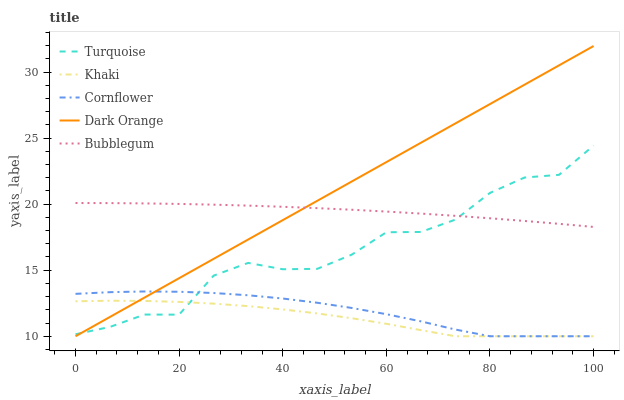Does Khaki have the minimum area under the curve?
Answer yes or no. Yes. Does Dark Orange have the maximum area under the curve?
Answer yes or no. Yes. Does Turquoise have the minimum area under the curve?
Answer yes or no. No. Does Turquoise have the maximum area under the curve?
Answer yes or no. No. Is Dark Orange the smoothest?
Answer yes or no. Yes. Is Turquoise the roughest?
Answer yes or no. Yes. Is Khaki the smoothest?
Answer yes or no. No. Is Khaki the roughest?
Answer yes or no. No. Does Cornflower have the lowest value?
Answer yes or no. Yes. Does Turquoise have the lowest value?
Answer yes or no. No. Does Dark Orange have the highest value?
Answer yes or no. Yes. Does Turquoise have the highest value?
Answer yes or no. No. Is Khaki less than Bubblegum?
Answer yes or no. Yes. Is Bubblegum greater than Cornflower?
Answer yes or no. Yes. Does Cornflower intersect Turquoise?
Answer yes or no. Yes. Is Cornflower less than Turquoise?
Answer yes or no. No. Is Cornflower greater than Turquoise?
Answer yes or no. No. Does Khaki intersect Bubblegum?
Answer yes or no. No. 